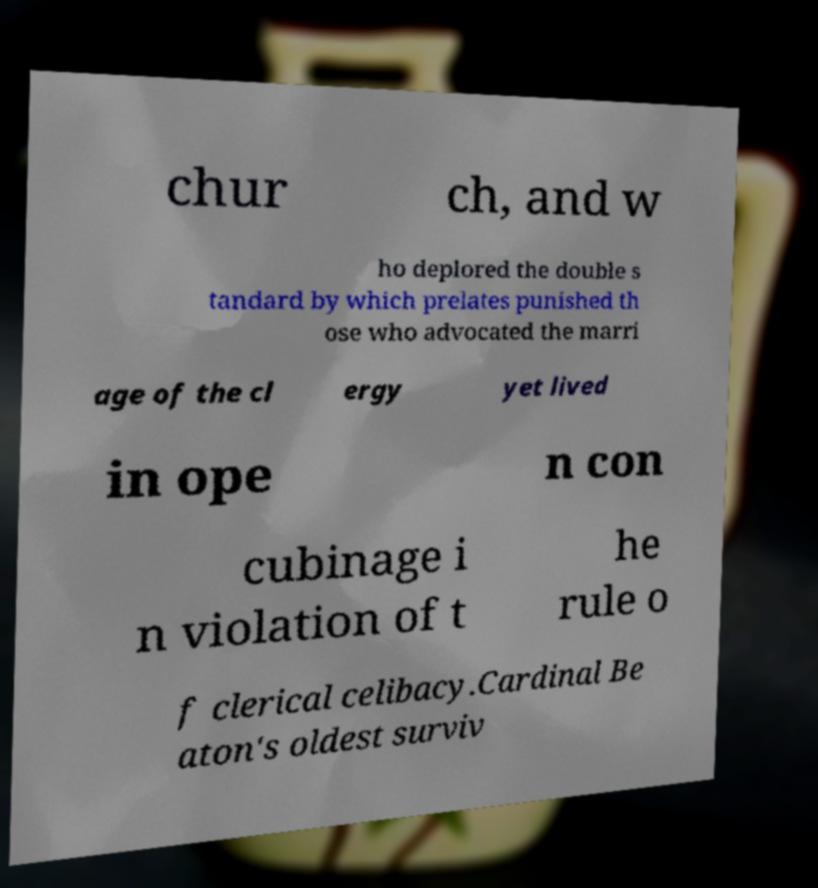Can you accurately transcribe the text from the provided image for me? chur ch, and w ho deplored the double s tandard by which prelates punished th ose who advocated the marri age of the cl ergy yet lived in ope n con cubinage i n violation of t he rule o f clerical celibacy.Cardinal Be aton's oldest surviv 